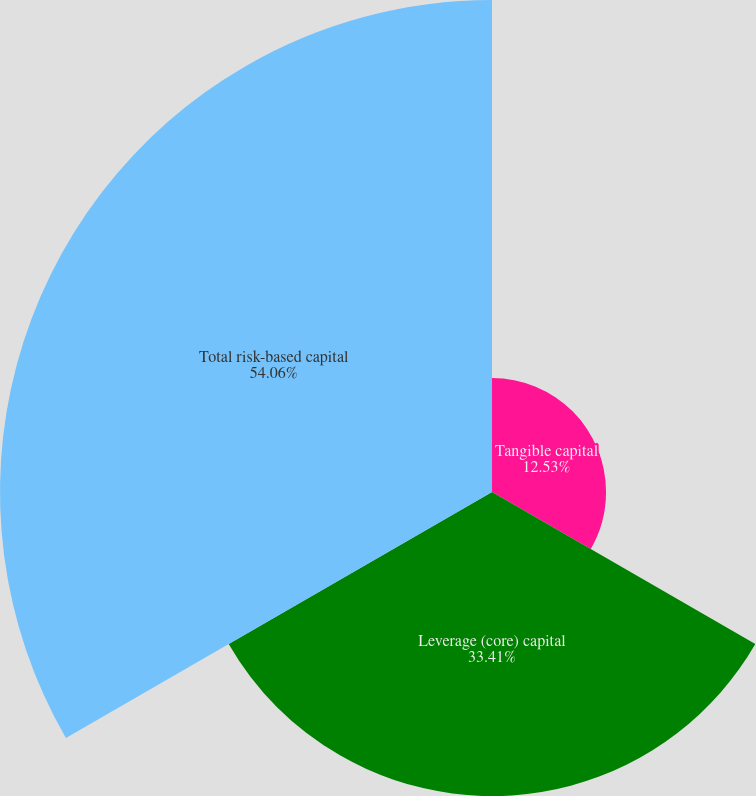Convert chart. <chart><loc_0><loc_0><loc_500><loc_500><pie_chart><fcel>Tangible capital<fcel>Leverage (core) capital<fcel>Total risk-based capital<nl><fcel>12.53%<fcel>33.41%<fcel>54.06%<nl></chart> 